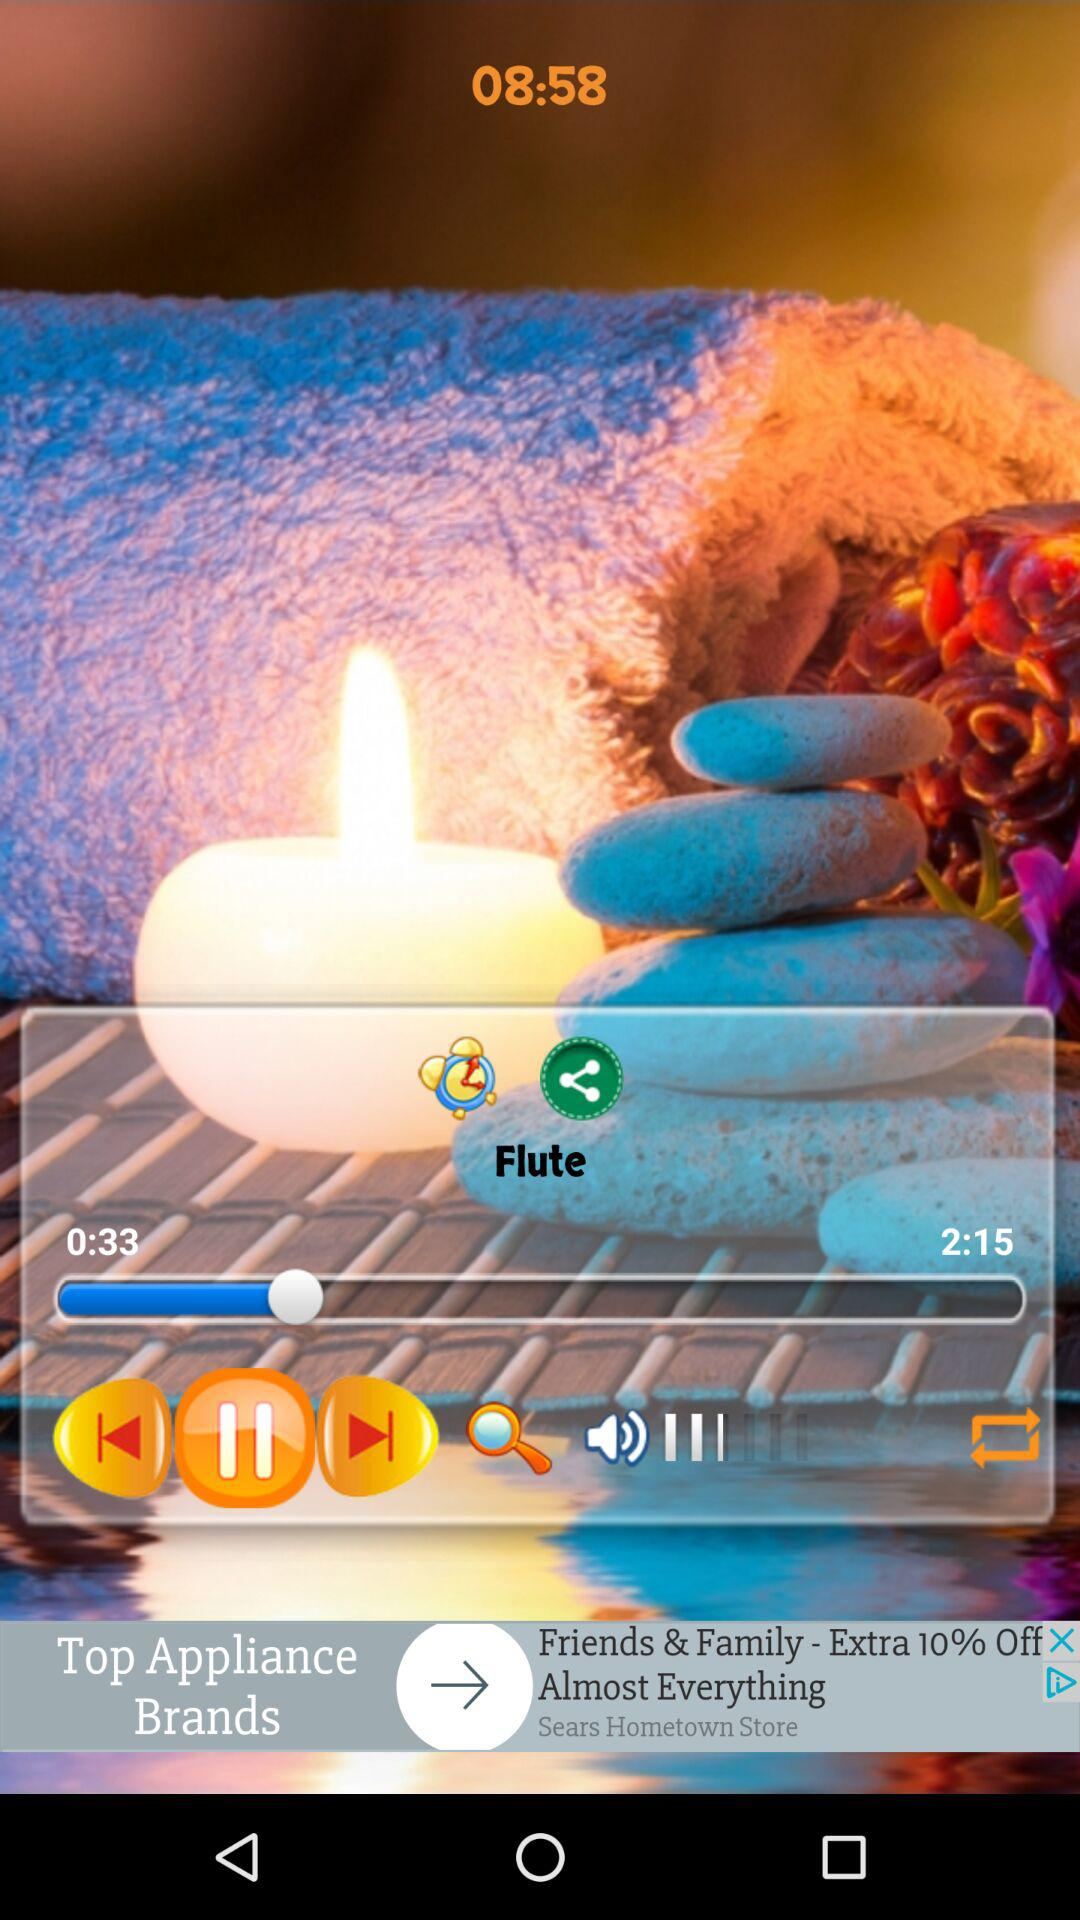For how long has the audio been played? The audio has been played for 33 seconds. 